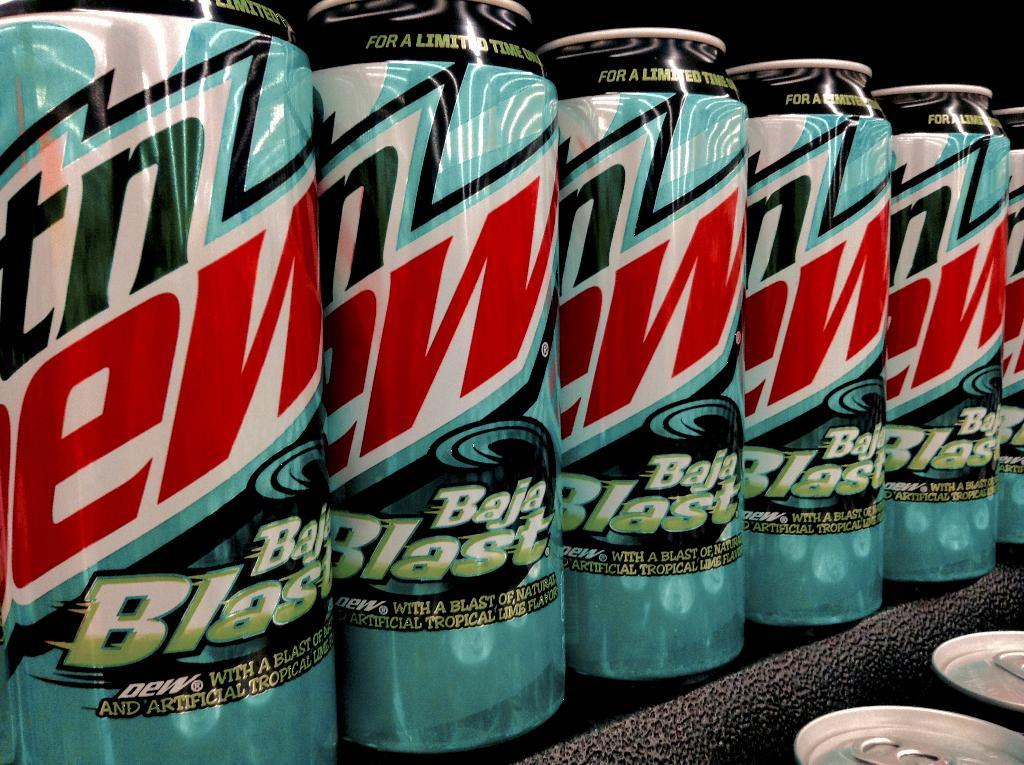<image>
Give a short and clear explanation of the subsequent image. Mtn Dew Baja Blast cans are on a shelf. 